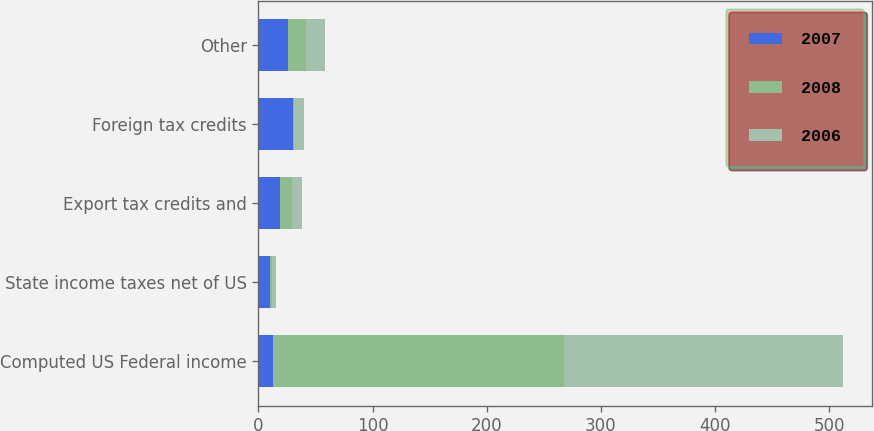Convert chart to OTSL. <chart><loc_0><loc_0><loc_500><loc_500><stacked_bar_chart><ecel><fcel>Computed US Federal income<fcel>State income taxes net of US<fcel>Export tax credits and<fcel>Foreign tax credits<fcel>Other<nl><fcel>2007<fcel>13.05<fcel>10.1<fcel>18.6<fcel>30.7<fcel>26.3<nl><fcel>2008<fcel>254.7<fcel>1.9<fcel>10.5<fcel>0.5<fcel>15.6<nl><fcel>2006<fcel>244.5<fcel>3.5<fcel>9.1<fcel>8.5<fcel>16<nl></chart> 